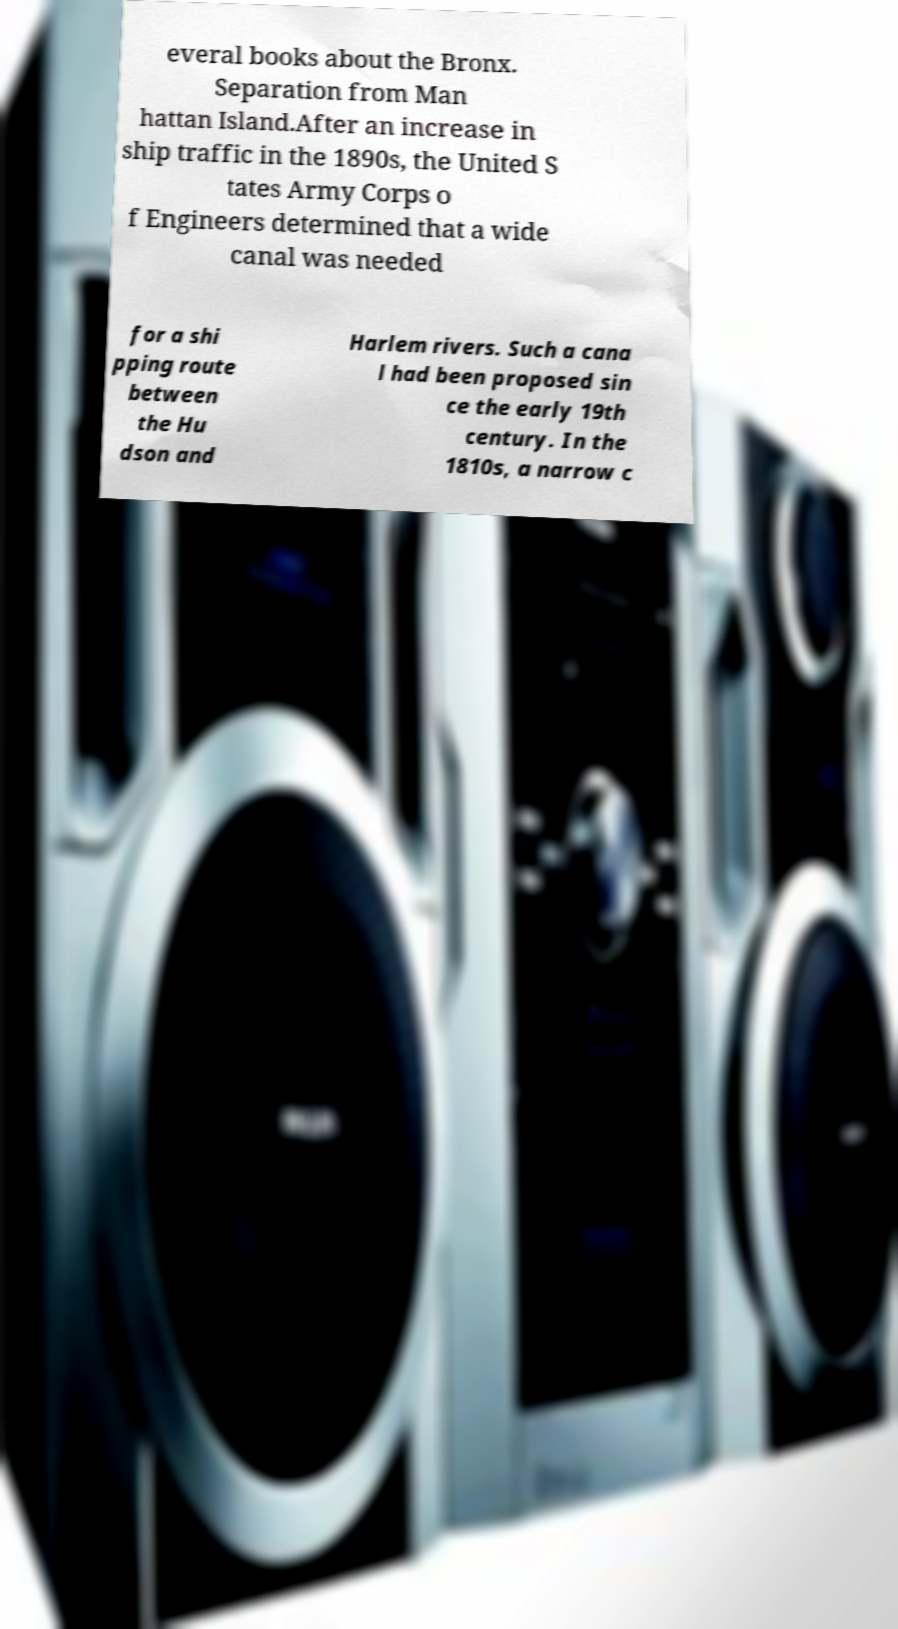For documentation purposes, I need the text within this image transcribed. Could you provide that? everal books about the Bronx. Separation from Man hattan Island.After an increase in ship traffic in the 1890s, the United S tates Army Corps o f Engineers determined that a wide canal was needed for a shi pping route between the Hu dson and Harlem rivers. Such a cana l had been proposed sin ce the early 19th century. In the 1810s, a narrow c 